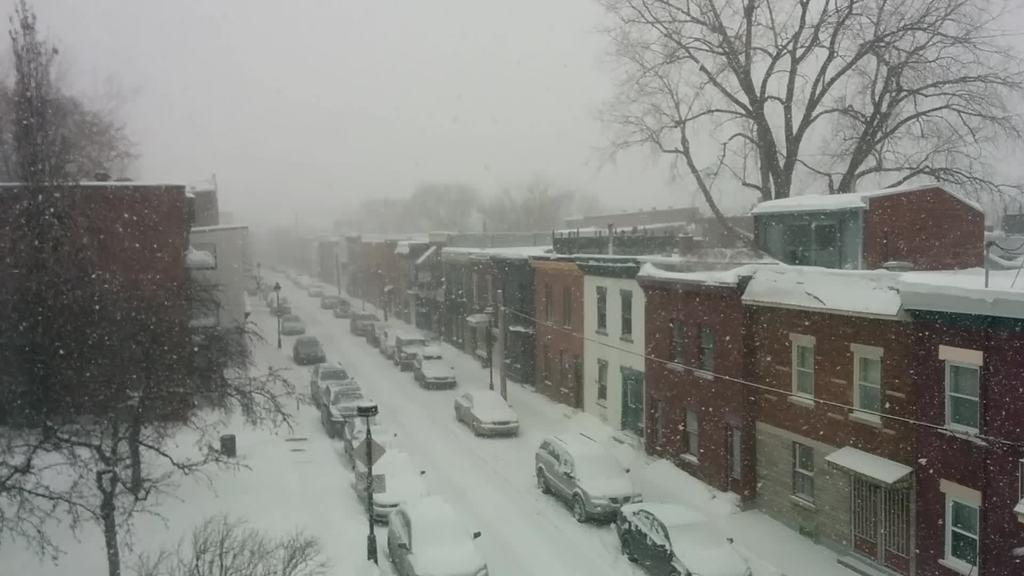What is the main feature of the image? There is a road in the image. What is happening on the road? Cars are present on the road. What can be seen on either side of the road? Buildings are visible on either side of the road. How does the weather appear in the image? The road, buildings, and cars are covered with snow. What is visible in the background of the image? There are trees in the background of the image. What type of string is being used to balance the lunch on the roof of the car in the image? There is no string or lunch present on the roof of a car in the image. 